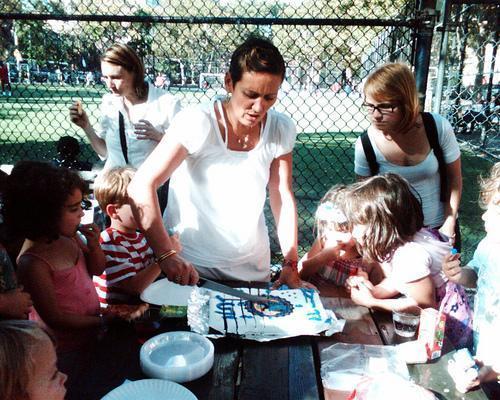How many people are there?
Give a very brief answer. 9. 